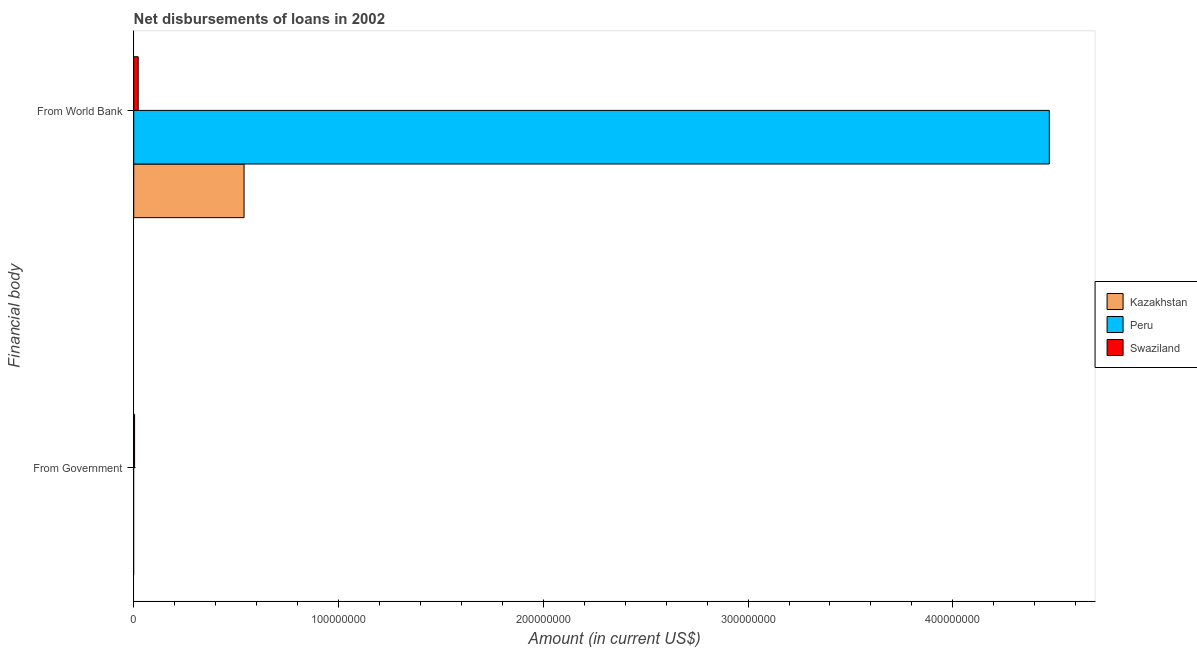Are the number of bars on each tick of the Y-axis equal?
Ensure brevity in your answer.  No. How many bars are there on the 1st tick from the top?
Offer a terse response. 3. What is the label of the 2nd group of bars from the top?
Ensure brevity in your answer.  From Government. What is the net disbursements of loan from world bank in Peru?
Your answer should be compact. 4.47e+08. Across all countries, what is the maximum net disbursements of loan from world bank?
Make the answer very short. 4.47e+08. Across all countries, what is the minimum net disbursements of loan from government?
Ensure brevity in your answer.  0. In which country was the net disbursements of loan from government maximum?
Your answer should be very brief. Swaziland. What is the total net disbursements of loan from world bank in the graph?
Make the answer very short. 5.03e+08. What is the difference between the net disbursements of loan from world bank in Kazakhstan and that in Swaziland?
Keep it short and to the point. 5.17e+07. What is the difference between the net disbursements of loan from government in Swaziland and the net disbursements of loan from world bank in Kazakhstan?
Your response must be concise. -5.35e+07. What is the average net disbursements of loan from government per country?
Your answer should be very brief. 1.37e+05. What is the difference between the net disbursements of loan from world bank and net disbursements of loan from government in Swaziland?
Ensure brevity in your answer.  1.76e+06. What is the ratio of the net disbursements of loan from world bank in Swaziland to that in Peru?
Provide a succinct answer. 0. Is the net disbursements of loan from world bank in Peru less than that in Kazakhstan?
Your response must be concise. No. How many bars are there?
Make the answer very short. 4. Does the graph contain any zero values?
Your answer should be compact. Yes. How many legend labels are there?
Give a very brief answer. 3. What is the title of the graph?
Offer a very short reply. Net disbursements of loans in 2002. What is the label or title of the X-axis?
Keep it short and to the point. Amount (in current US$). What is the label or title of the Y-axis?
Your answer should be compact. Financial body. What is the Amount (in current US$) in Kazakhstan in From Government?
Provide a succinct answer. 0. What is the Amount (in current US$) of Peru in From Government?
Offer a terse response. 0. What is the Amount (in current US$) of Swaziland in From Government?
Your response must be concise. 4.11e+05. What is the Amount (in current US$) in Kazakhstan in From World Bank?
Keep it short and to the point. 5.39e+07. What is the Amount (in current US$) of Peru in From World Bank?
Your answer should be compact. 4.47e+08. What is the Amount (in current US$) in Swaziland in From World Bank?
Your answer should be compact. 2.17e+06. Across all Financial body, what is the maximum Amount (in current US$) of Kazakhstan?
Make the answer very short. 5.39e+07. Across all Financial body, what is the maximum Amount (in current US$) in Peru?
Offer a terse response. 4.47e+08. Across all Financial body, what is the maximum Amount (in current US$) in Swaziland?
Keep it short and to the point. 2.17e+06. Across all Financial body, what is the minimum Amount (in current US$) of Kazakhstan?
Your answer should be very brief. 0. Across all Financial body, what is the minimum Amount (in current US$) of Swaziland?
Offer a terse response. 4.11e+05. What is the total Amount (in current US$) of Kazakhstan in the graph?
Offer a very short reply. 5.39e+07. What is the total Amount (in current US$) in Peru in the graph?
Keep it short and to the point. 4.47e+08. What is the total Amount (in current US$) of Swaziland in the graph?
Make the answer very short. 2.58e+06. What is the difference between the Amount (in current US$) of Swaziland in From Government and that in From World Bank?
Your response must be concise. -1.76e+06. What is the average Amount (in current US$) of Kazakhstan per Financial body?
Your response must be concise. 2.69e+07. What is the average Amount (in current US$) in Peru per Financial body?
Your answer should be compact. 2.24e+08. What is the average Amount (in current US$) of Swaziland per Financial body?
Offer a terse response. 1.29e+06. What is the difference between the Amount (in current US$) of Kazakhstan and Amount (in current US$) of Peru in From World Bank?
Make the answer very short. -3.93e+08. What is the difference between the Amount (in current US$) in Kazakhstan and Amount (in current US$) in Swaziland in From World Bank?
Your response must be concise. 5.17e+07. What is the difference between the Amount (in current US$) in Peru and Amount (in current US$) in Swaziland in From World Bank?
Your response must be concise. 4.45e+08. What is the ratio of the Amount (in current US$) in Swaziland in From Government to that in From World Bank?
Keep it short and to the point. 0.19. What is the difference between the highest and the second highest Amount (in current US$) of Swaziland?
Ensure brevity in your answer.  1.76e+06. What is the difference between the highest and the lowest Amount (in current US$) of Kazakhstan?
Your answer should be very brief. 5.39e+07. What is the difference between the highest and the lowest Amount (in current US$) of Peru?
Make the answer very short. 4.47e+08. What is the difference between the highest and the lowest Amount (in current US$) in Swaziland?
Your answer should be compact. 1.76e+06. 